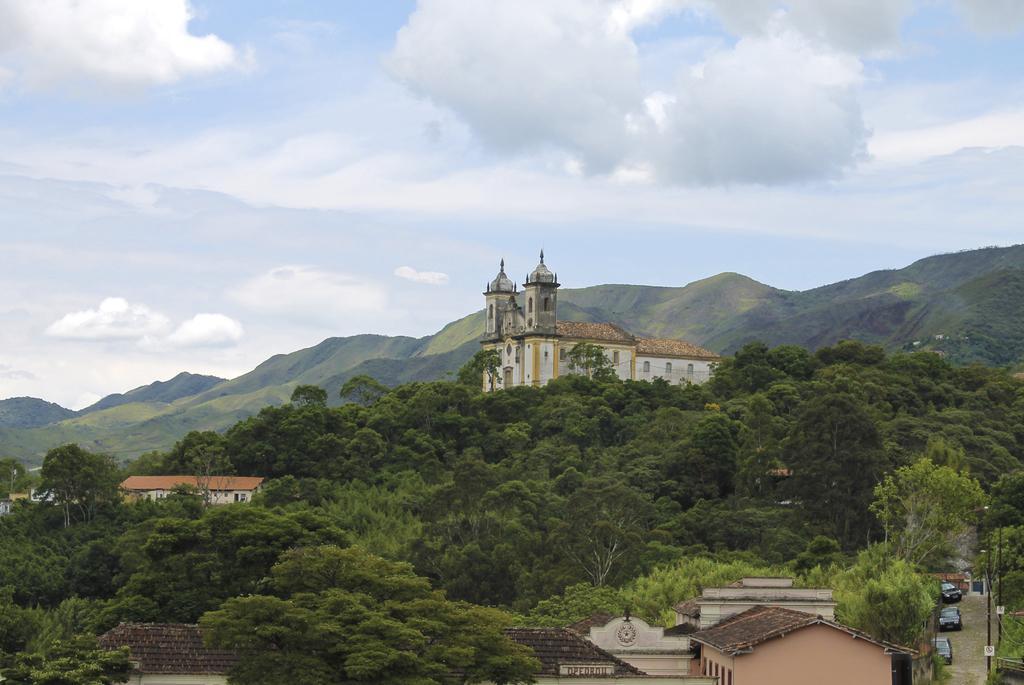How would you summarize this image in a sentence or two? There are trees at here, in the middle there is a big house. At the top it's a cloudy sky. 